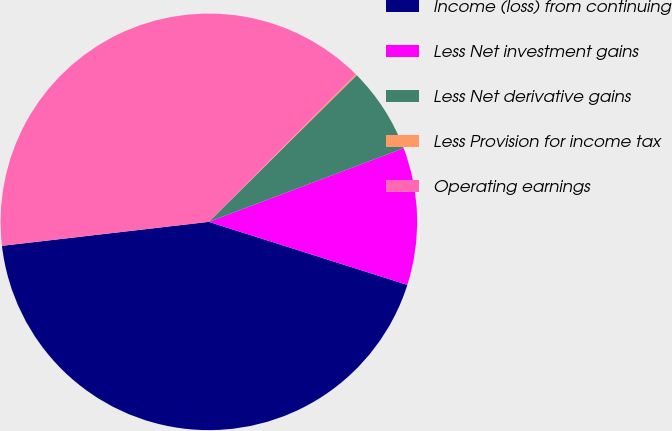Convert chart. <chart><loc_0><loc_0><loc_500><loc_500><pie_chart><fcel>Income (loss) from continuing<fcel>Less Net investment gains<fcel>Less Net derivative gains<fcel>Less Provision for income tax<fcel>Operating earnings<nl><fcel>43.27%<fcel>10.65%<fcel>6.68%<fcel>0.1%<fcel>39.3%<nl></chart> 